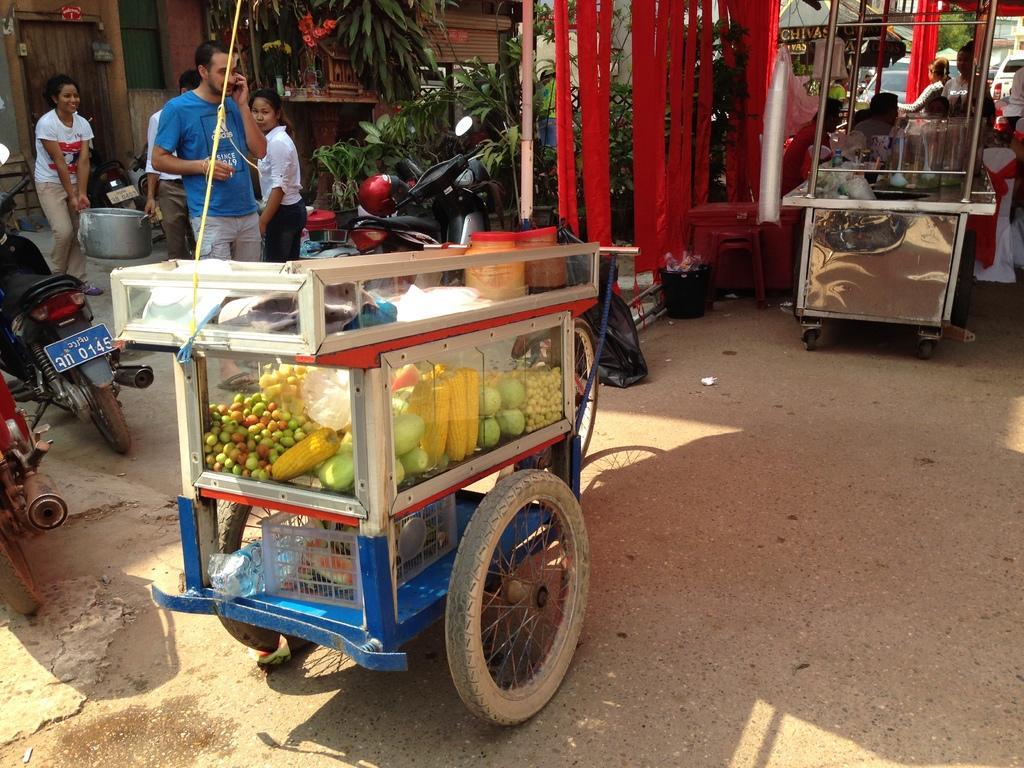In one or two sentences, can you explain what this image depicts? In the picture I can see a vehicle which has few eatables placed in it and there are two bikes in the left corner and there are few people,vehicles and some other objects in the background. 